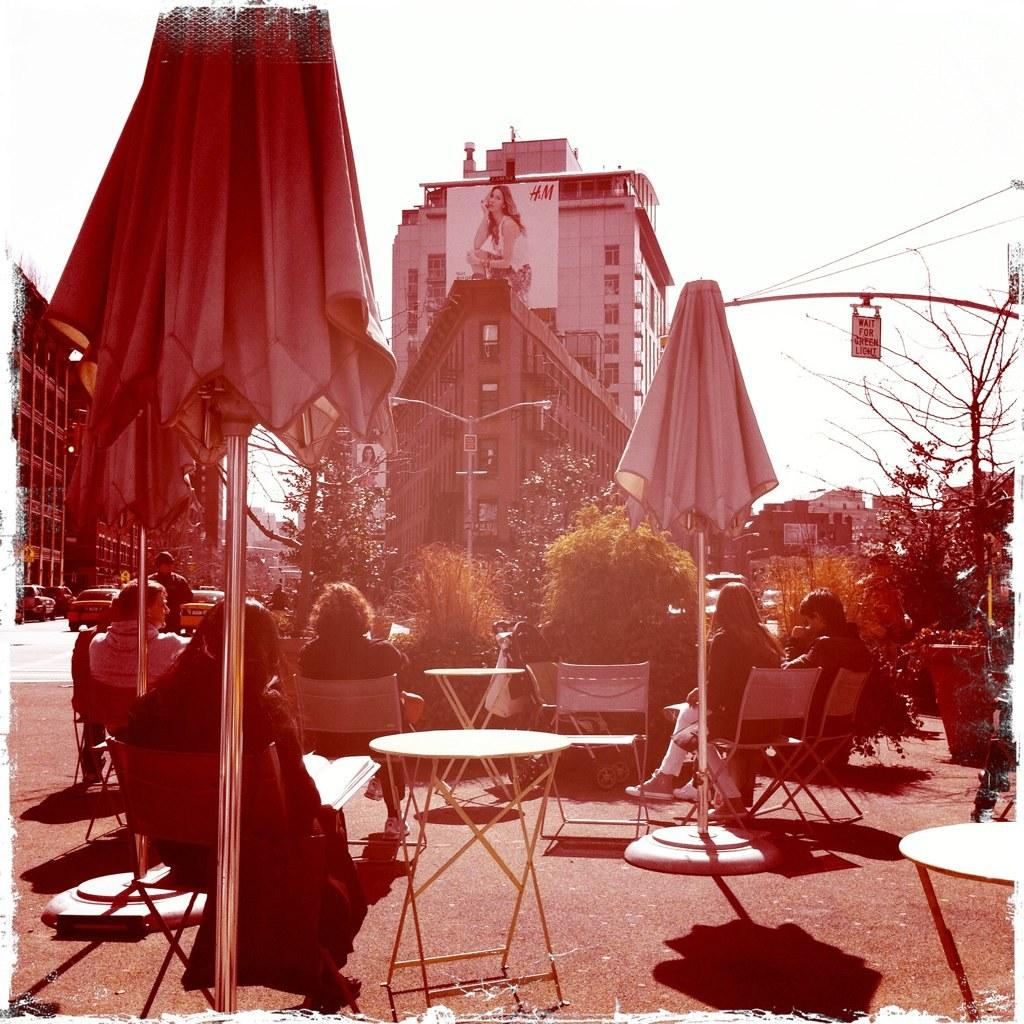What are the people in the image doing? People are sitting in chairs at a restaurant. What can be seen in the background of the image? There is a building in the background. What is on the building? There is a hoarding on the building. What is the condition of the sky in the image? The sky is clear in the image. Can you tell me how many toes the people in the image have? There is no information about the number of toes the people in the image have, as we cannot see their feet. What type of calculator is being used by the people in the image? There is no calculator present in the image. 